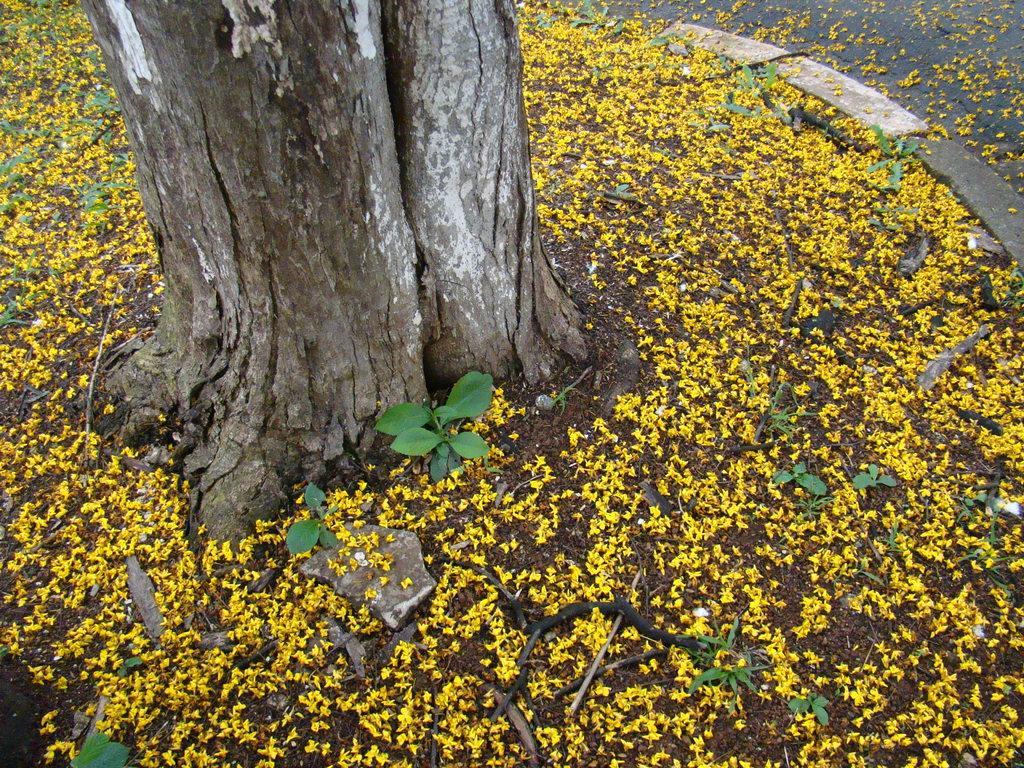Describe this image in one or two sentences. In this picture there is a trunk at the top side of the image and there are sticks and flowers on the floor, which are yellow in color. 